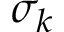Convert formula to latex. <formula><loc_0><loc_0><loc_500><loc_500>\sigma _ { k }</formula> 